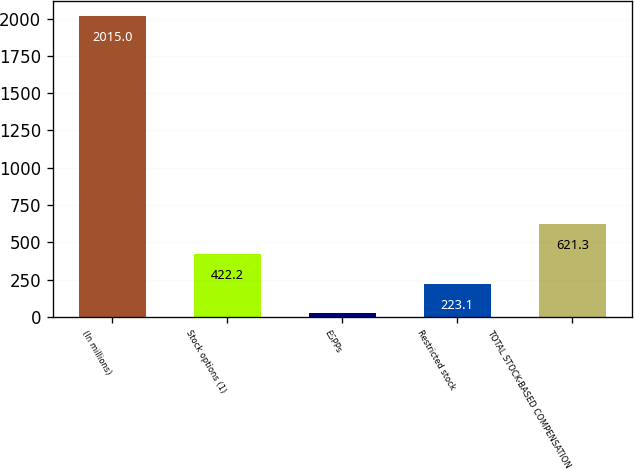Convert chart to OTSL. <chart><loc_0><loc_0><loc_500><loc_500><bar_chart><fcel>(In millions)<fcel>Stock options (1)<fcel>ESPPs<fcel>Restricted stock<fcel>TOTAL STOCK-BASED COMPENSATION<nl><fcel>2015<fcel>422.2<fcel>24<fcel>223.1<fcel>621.3<nl></chart> 